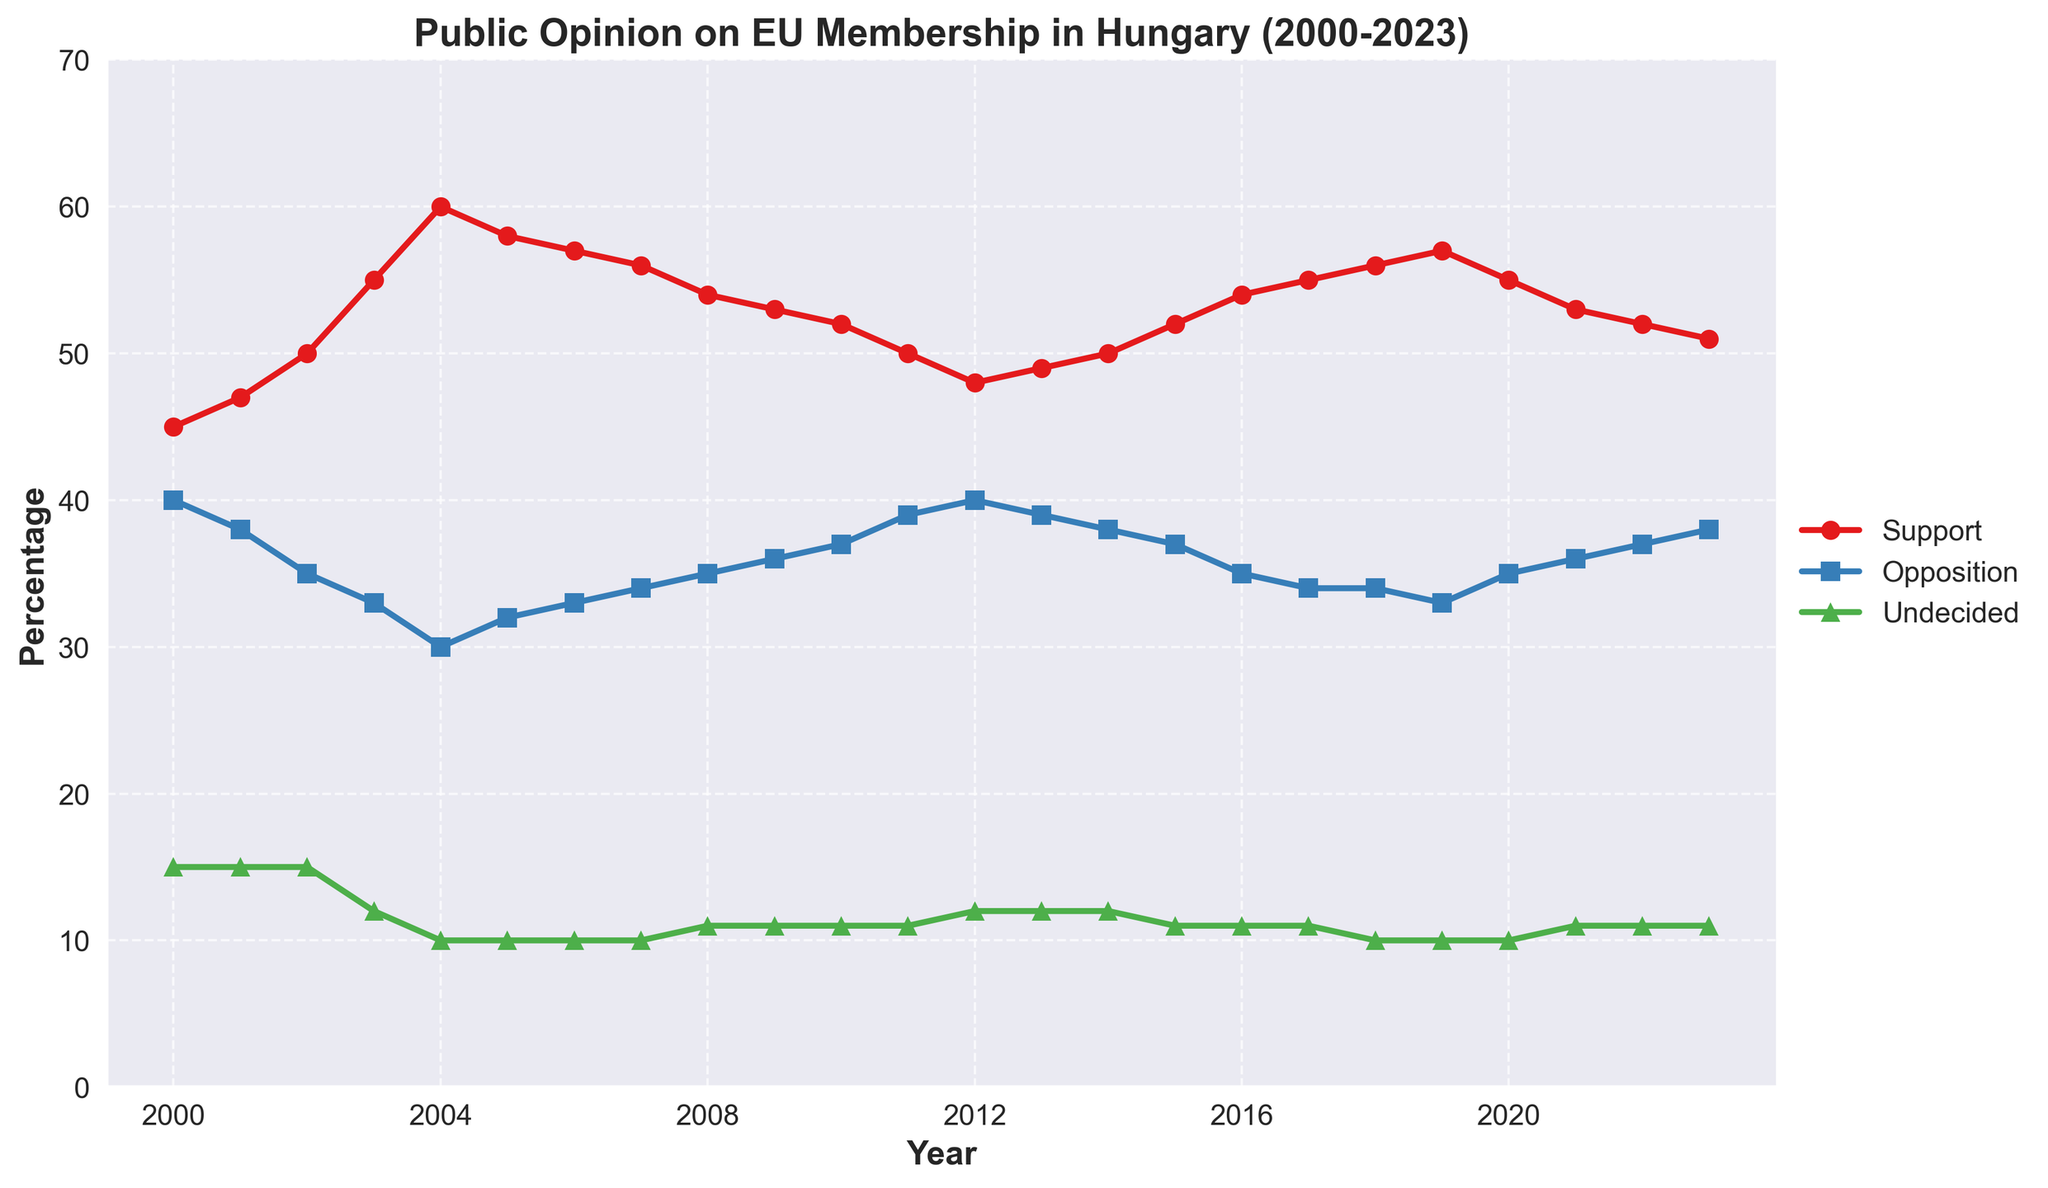What is the title of the plot? The title of the plot is typically written at the top of the figure, in this case it reads: "Public Opinion on EU Membership in Hungary (2000-2023)".
Answer: Public Opinion on EU Membership in Hungary (2000-2023) How many data lines are visible in the plot? The plot shows three distinct lines with different markers: circles for Support, squares for Opposition, and triangles for Undecided.
Answer: Three What was the support percentage for EU membership in 2004? To find this, locate the point on the 'Support' line that aligns with the year 2004 on the x-axis. The y-axis value for that year is 60%.
Answer: 60% In which year did the opposition to EU membership peak? Find the highest point on the 'Opposition' line by comparing all the y-axis values. The maximum value occurs at 40% in 2000 and 2012.
Answer: 2000 and 2012 What is the difference in support for EU membership between 2003 and 2009? Check the y-axis values for the 'Support' line in 2003 and 2009, which are 55% and 53% respectively. Subtract the latter from the former (55% - 53%).
Answer: 2% During which year(s) did the percentage of undecided people remain constant? Look for periods where the 'Undecided' line is flat. Between 2004 and 2011, the percentage remains constant at various points. Specifically, at 10% from 2004 to 2006 and at 11% from 2011 to 2023.
Answer: 2004-2006, 2011-2023 What is the average support for EU membership in the years between 2015 and 2020 inclusive? Add the support percentages for 2015, 2016, 2017, 2018, 2019, and 2020 (52% + 54% + 55% + 56% + 57% + 55%) and divide by 6. The sum is 329%, so the average is 329/6.
Answer: 54.83% What trend is visible in the opposition percentages from 2016 to 2023? Look at the y-axis values on the 'Opposition' line between 2016 and 2023. The values increase from 34% in 2016 to 38% in 2023, indicating a slight upward trend.
Answer: Increasing Which year's support values for EU membership are equal to the opposition values? Identify the year where the support and opposition percentages are the same by tracking both lines. The values never intersect, meaning support is never equal to opposition in any given year.
Answer: None What is the overall trend in public opinion towards EU membership from 2000 to 2023? Assess the 'Support', 'Opposition', and 'Undecided' lines from start to end. Support increased initially, peaked around 2004, and slightly declined afterward. Opposition shows a somewhat steady slight increase from 2000 onwards. Undecided remains relatively stable, slightly decreasing.
Answer: Mixed (Initial increase in Support, slight decline later; steady Opposition increase; stable Undecided) 